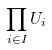<formula> <loc_0><loc_0><loc_500><loc_500>\prod _ { i \in I } U _ { i }</formula> 